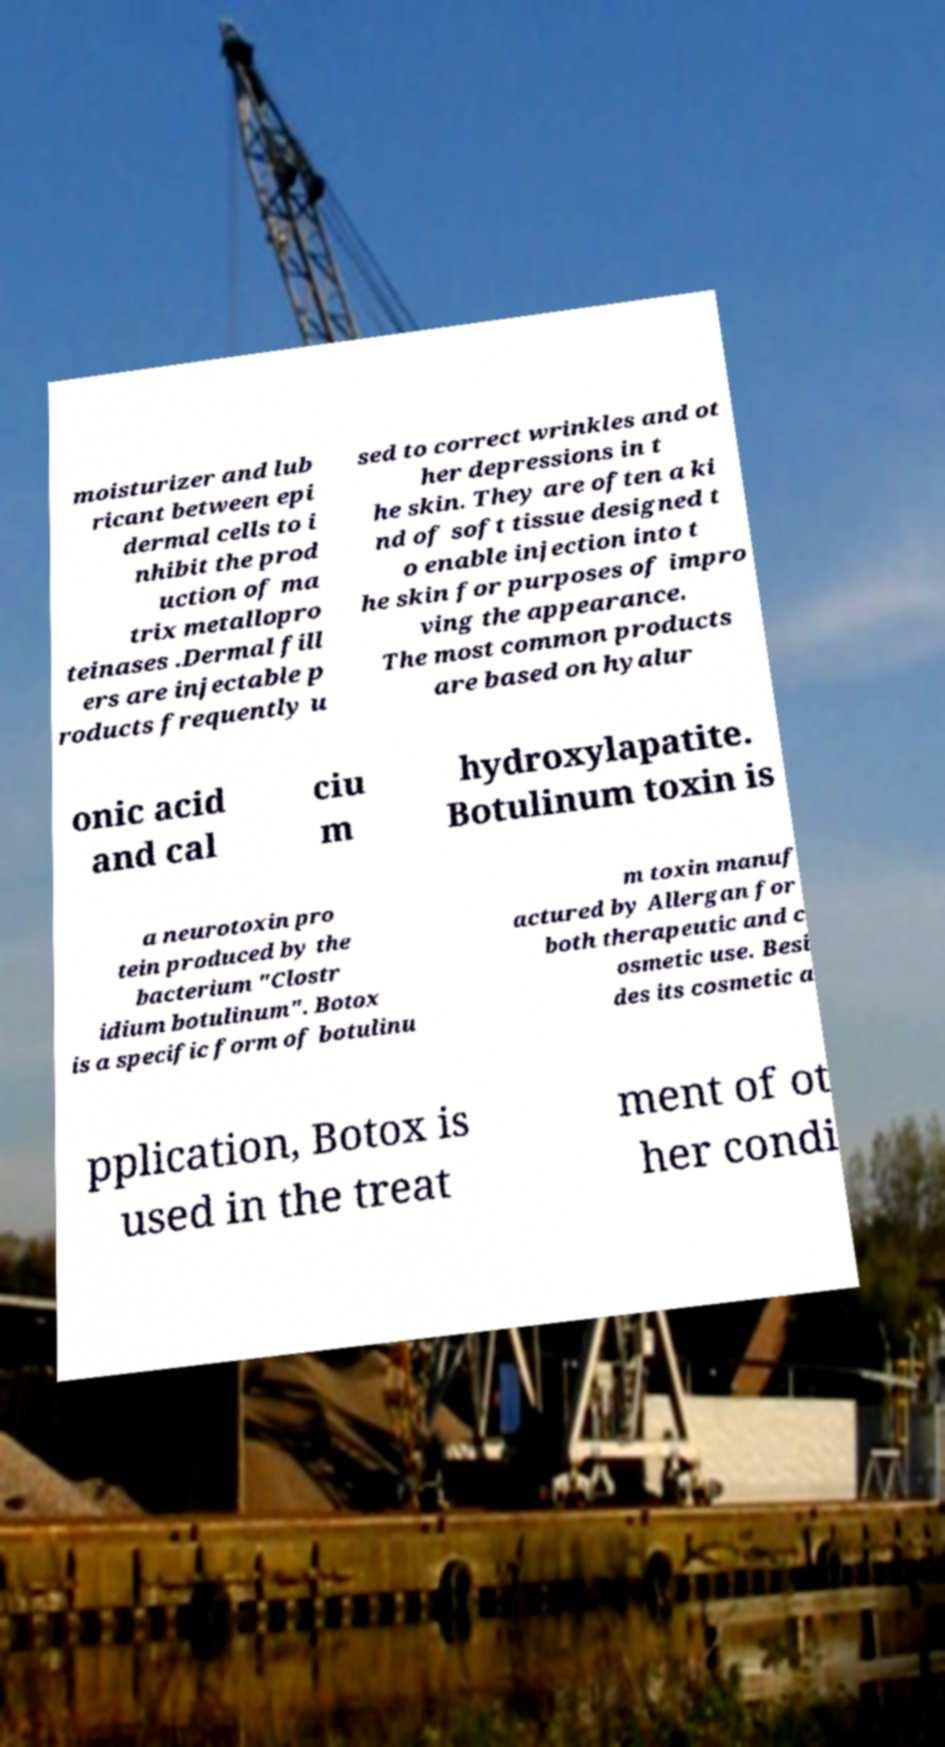Can you read and provide the text displayed in the image?This photo seems to have some interesting text. Can you extract and type it out for me? moisturizer and lub ricant between epi dermal cells to i nhibit the prod uction of ma trix metallopro teinases .Dermal fill ers are injectable p roducts frequently u sed to correct wrinkles and ot her depressions in t he skin. They are often a ki nd of soft tissue designed t o enable injection into t he skin for purposes of impro ving the appearance. The most common products are based on hyalur onic acid and cal ciu m hydroxylapatite. Botulinum toxin is a neurotoxin pro tein produced by the bacterium "Clostr idium botulinum". Botox is a specific form of botulinu m toxin manuf actured by Allergan for both therapeutic and c osmetic use. Besi des its cosmetic a pplication, Botox is used in the treat ment of ot her condi 